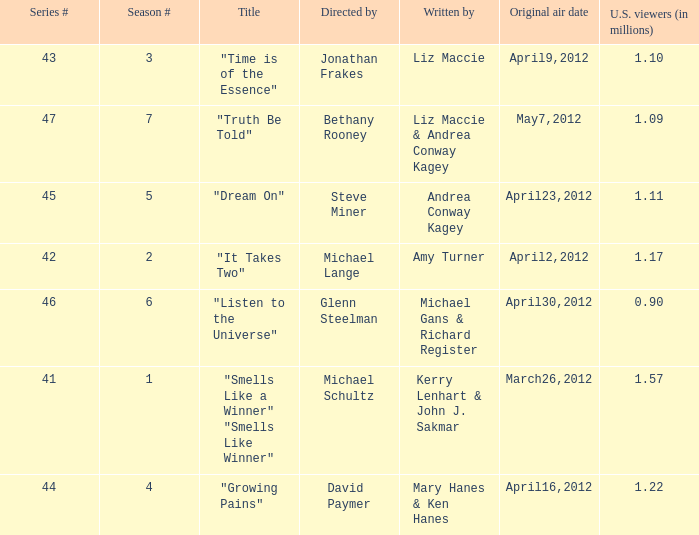What is the name of the episodes which had 1.22 million U.S. viewers? "Growing Pains". 